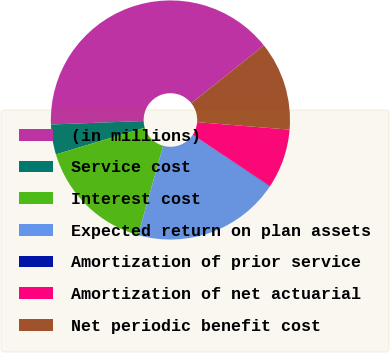Convert chart to OTSL. <chart><loc_0><loc_0><loc_500><loc_500><pie_chart><fcel>(in millions)<fcel>Service cost<fcel>Interest cost<fcel>Expected return on plan assets<fcel>Amortization of prior service<fcel>Amortization of net actuarial<fcel>Net periodic benefit cost<nl><fcel>39.88%<fcel>4.05%<fcel>15.99%<fcel>19.97%<fcel>0.07%<fcel>8.03%<fcel>12.01%<nl></chart> 